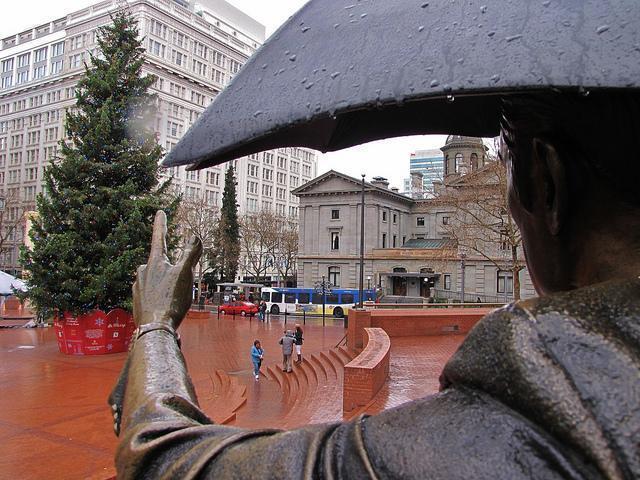When does this season take place?
Select the accurate response from the four choices given to answer the question.
Options: Spring, summer, fall, winter. Winter. 